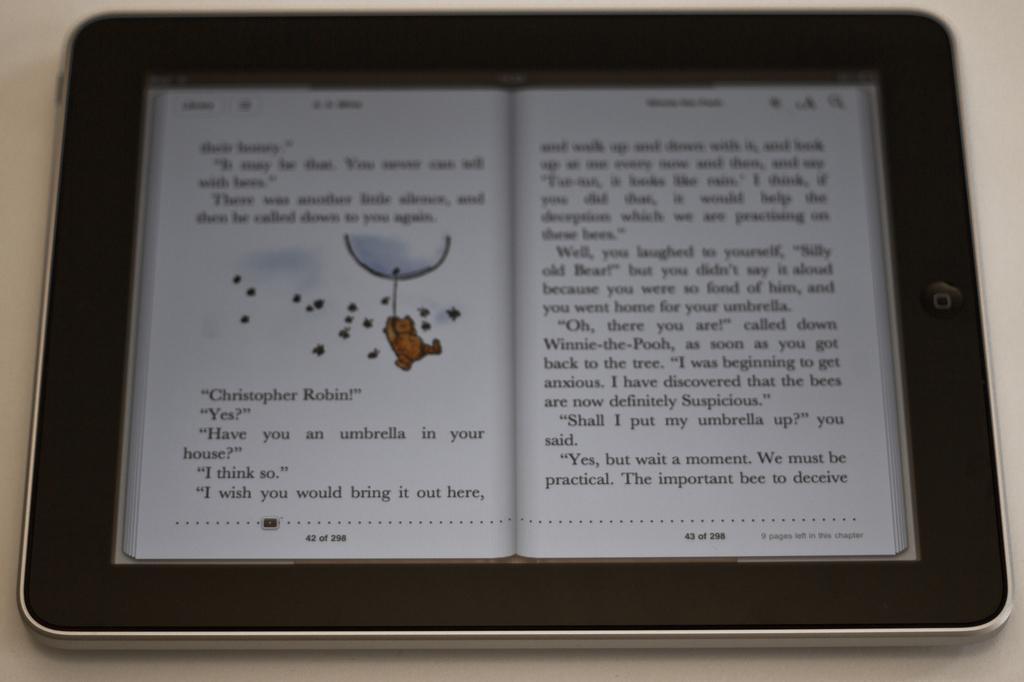<image>
Render a clear and concise summary of the photo. An e-reader shows the pages of a children's book where a character calls out "Christopher Robin!". 